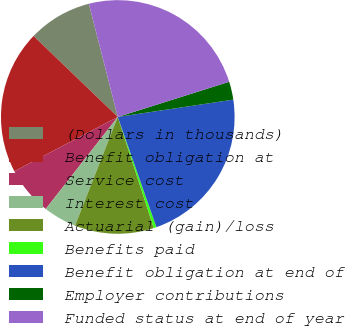Convert chart to OTSL. <chart><loc_0><loc_0><loc_500><loc_500><pie_chart><fcel>(Dollars in thousands)<fcel>Benefit obligation at<fcel>Service cost<fcel>Interest cost<fcel>Actuarial (gain)/loss<fcel>Benefits paid<fcel>Benefit obligation at end of<fcel>Employer contributions<fcel>Funded status at end of year<nl><fcel>8.84%<fcel>19.88%<fcel>6.73%<fcel>4.61%<fcel>10.95%<fcel>0.38%<fcel>22.0%<fcel>2.5%<fcel>24.11%<nl></chart> 